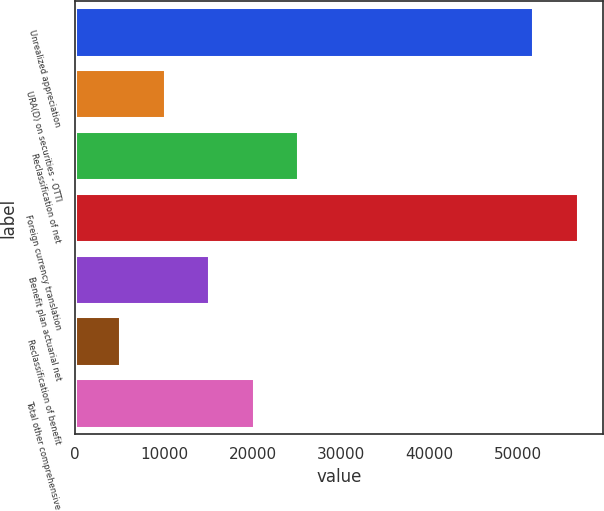Convert chart to OTSL. <chart><loc_0><loc_0><loc_500><loc_500><bar_chart><fcel>Unrealized appreciation<fcel>URA(D) on securities - OTTI<fcel>Reclassification of net<fcel>Foreign currency translation<fcel>Benefit plan actuarial net<fcel>Reclassification of benefit<fcel>Total other comprehensive<nl><fcel>51684<fcel>10099.8<fcel>25180.2<fcel>56710.8<fcel>15126.6<fcel>5073<fcel>20153.4<nl></chart> 